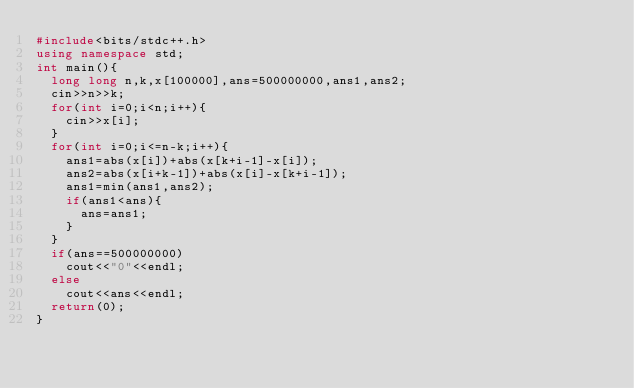Convert code to text. <code><loc_0><loc_0><loc_500><loc_500><_C++_>#include<bits/stdc++.h>
using namespace std;
int main(){
	long long n,k,x[100000],ans=500000000,ans1,ans2;
	cin>>n>>k;
	for(int i=0;i<n;i++){
		cin>>x[i];
	}
	for(int i=0;i<=n-k;i++){
		ans1=abs(x[i])+abs(x[k+i-1]-x[i]);
		ans2=abs(x[i+k-1])+abs(x[i]-x[k+i-1]);
		ans1=min(ans1,ans2);
		if(ans1<ans){
			ans=ans1;
		}
	}
	if(ans==500000000)
		cout<<"0"<<endl;
	else
		cout<<ans<<endl;
  return(0);
}</code> 